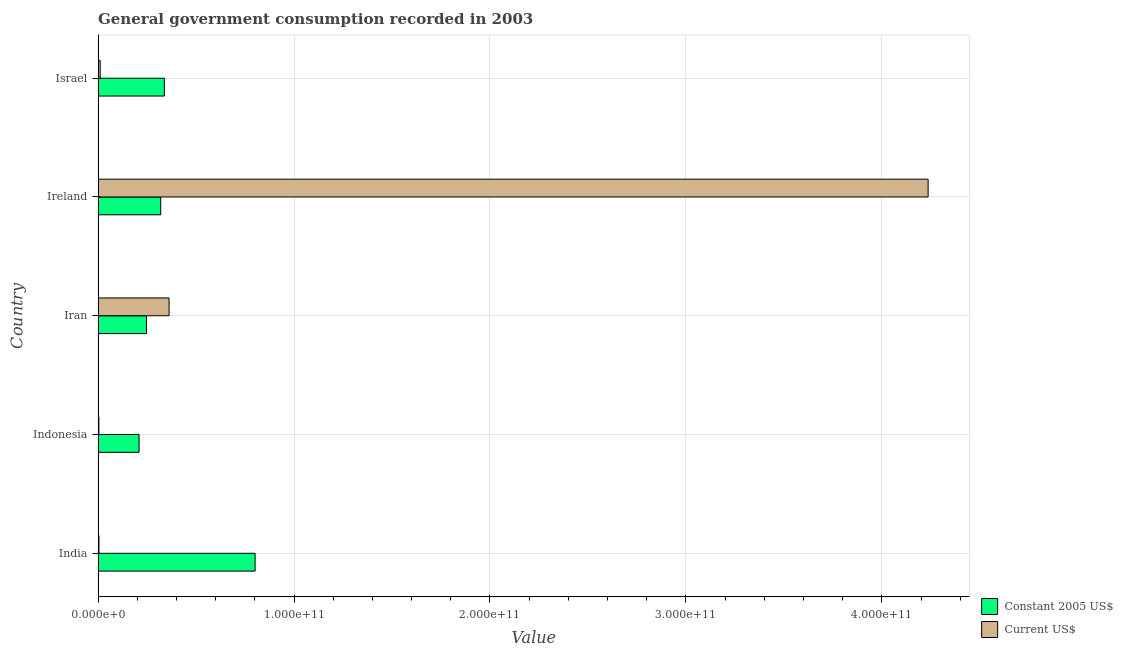How many groups of bars are there?
Your answer should be compact. 5. Are the number of bars on each tick of the Y-axis equal?
Your answer should be compact. Yes. What is the label of the 3rd group of bars from the top?
Offer a very short reply. Iran. What is the value consumed in constant 2005 us$ in Iran?
Your answer should be very brief. 2.47e+1. Across all countries, what is the maximum value consumed in current us$?
Provide a short and direct response. 4.24e+11. Across all countries, what is the minimum value consumed in current us$?
Your response must be concise. 3.86e+08. In which country was the value consumed in constant 2005 us$ maximum?
Your answer should be compact. India. In which country was the value consumed in current us$ minimum?
Your answer should be compact. Indonesia. What is the total value consumed in constant 2005 us$ in the graph?
Your answer should be compact. 1.91e+11. What is the difference between the value consumed in current us$ in Ireland and that in Israel?
Ensure brevity in your answer.  4.23e+11. What is the difference between the value consumed in current us$ in Iran and the value consumed in constant 2005 us$ in Israel?
Offer a terse response. 2.40e+09. What is the average value consumed in current us$ per country?
Your response must be concise. 9.23e+1. What is the difference between the value consumed in constant 2005 us$ and value consumed in current us$ in Ireland?
Offer a very short reply. -3.92e+11. In how many countries, is the value consumed in constant 2005 us$ greater than 20000000000 ?
Make the answer very short. 5. What is the ratio of the value consumed in constant 2005 us$ in Iran to that in Ireland?
Provide a succinct answer. 0.77. What is the difference between the highest and the second highest value consumed in current us$?
Provide a short and direct response. 3.87e+11. What is the difference between the highest and the lowest value consumed in current us$?
Provide a short and direct response. 4.23e+11. In how many countries, is the value consumed in current us$ greater than the average value consumed in current us$ taken over all countries?
Keep it short and to the point. 1. What does the 1st bar from the top in Indonesia represents?
Your answer should be compact. Current US$. What does the 2nd bar from the bottom in Ireland represents?
Give a very brief answer. Current US$. How many bars are there?
Keep it short and to the point. 10. Are all the bars in the graph horizontal?
Provide a short and direct response. Yes. What is the difference between two consecutive major ticks on the X-axis?
Give a very brief answer. 1.00e+11. Are the values on the major ticks of X-axis written in scientific E-notation?
Keep it short and to the point. Yes. Does the graph contain any zero values?
Keep it short and to the point. No. Where does the legend appear in the graph?
Make the answer very short. Bottom right. How are the legend labels stacked?
Your response must be concise. Vertical. What is the title of the graph?
Provide a succinct answer. General government consumption recorded in 2003. Does "Methane emissions" appear as one of the legend labels in the graph?
Provide a short and direct response. No. What is the label or title of the X-axis?
Provide a succinct answer. Value. What is the Value of Constant 2005 US$ in India?
Offer a terse response. 8.01e+1. What is the Value in Current US$ in India?
Provide a succinct answer. 4.29e+08. What is the Value in Constant 2005 US$ in Indonesia?
Your response must be concise. 2.09e+1. What is the Value in Current US$ in Indonesia?
Your response must be concise. 3.86e+08. What is the Value in Constant 2005 US$ in Iran?
Your answer should be very brief. 2.47e+1. What is the Value in Current US$ in Iran?
Give a very brief answer. 3.62e+1. What is the Value of Constant 2005 US$ in Ireland?
Keep it short and to the point. 3.19e+1. What is the Value of Current US$ in Ireland?
Your response must be concise. 4.24e+11. What is the Value in Constant 2005 US$ in Israel?
Your answer should be very brief. 3.38e+1. What is the Value in Current US$ in Israel?
Keep it short and to the point. 1.05e+09. Across all countries, what is the maximum Value in Constant 2005 US$?
Your response must be concise. 8.01e+1. Across all countries, what is the maximum Value of Current US$?
Ensure brevity in your answer.  4.24e+11. Across all countries, what is the minimum Value of Constant 2005 US$?
Provide a succinct answer. 2.09e+1. Across all countries, what is the minimum Value of Current US$?
Provide a short and direct response. 3.86e+08. What is the total Value in Constant 2005 US$ in the graph?
Provide a short and direct response. 1.91e+11. What is the total Value of Current US$ in the graph?
Provide a short and direct response. 4.62e+11. What is the difference between the Value of Constant 2005 US$ in India and that in Indonesia?
Your answer should be very brief. 5.92e+1. What is the difference between the Value of Current US$ in India and that in Indonesia?
Keep it short and to the point. 4.30e+07. What is the difference between the Value of Constant 2005 US$ in India and that in Iran?
Keep it short and to the point. 5.55e+1. What is the difference between the Value in Current US$ in India and that in Iran?
Your answer should be very brief. -3.58e+1. What is the difference between the Value of Constant 2005 US$ in India and that in Ireland?
Your answer should be compact. 4.82e+1. What is the difference between the Value of Current US$ in India and that in Ireland?
Provide a succinct answer. -4.23e+11. What is the difference between the Value of Constant 2005 US$ in India and that in Israel?
Provide a succinct answer. 4.63e+1. What is the difference between the Value in Current US$ in India and that in Israel?
Ensure brevity in your answer.  -6.24e+08. What is the difference between the Value of Constant 2005 US$ in Indonesia and that in Iran?
Your answer should be compact. -3.77e+09. What is the difference between the Value in Current US$ in Indonesia and that in Iran?
Make the answer very short. -3.58e+1. What is the difference between the Value in Constant 2005 US$ in Indonesia and that in Ireland?
Keep it short and to the point. -1.10e+1. What is the difference between the Value of Current US$ in Indonesia and that in Ireland?
Make the answer very short. -4.23e+11. What is the difference between the Value of Constant 2005 US$ in Indonesia and that in Israel?
Keep it short and to the point. -1.29e+1. What is the difference between the Value of Current US$ in Indonesia and that in Israel?
Make the answer very short. -6.67e+08. What is the difference between the Value in Constant 2005 US$ in Iran and that in Ireland?
Keep it short and to the point. -7.27e+09. What is the difference between the Value in Current US$ in Iran and that in Ireland?
Offer a terse response. -3.87e+11. What is the difference between the Value of Constant 2005 US$ in Iran and that in Israel?
Make the answer very short. -9.13e+09. What is the difference between the Value of Current US$ in Iran and that in Israel?
Give a very brief answer. 3.52e+1. What is the difference between the Value in Constant 2005 US$ in Ireland and that in Israel?
Offer a terse response. -1.86e+09. What is the difference between the Value in Current US$ in Ireland and that in Israel?
Provide a short and direct response. 4.23e+11. What is the difference between the Value in Constant 2005 US$ in India and the Value in Current US$ in Indonesia?
Ensure brevity in your answer.  7.97e+1. What is the difference between the Value in Constant 2005 US$ in India and the Value in Current US$ in Iran?
Provide a succinct answer. 4.39e+1. What is the difference between the Value of Constant 2005 US$ in India and the Value of Current US$ in Ireland?
Provide a succinct answer. -3.44e+11. What is the difference between the Value in Constant 2005 US$ in India and the Value in Current US$ in Israel?
Keep it short and to the point. 7.91e+1. What is the difference between the Value in Constant 2005 US$ in Indonesia and the Value in Current US$ in Iran?
Offer a very short reply. -1.53e+1. What is the difference between the Value of Constant 2005 US$ in Indonesia and the Value of Current US$ in Ireland?
Make the answer very short. -4.03e+11. What is the difference between the Value in Constant 2005 US$ in Indonesia and the Value in Current US$ in Israel?
Ensure brevity in your answer.  1.99e+1. What is the difference between the Value in Constant 2005 US$ in Iran and the Value in Current US$ in Ireland?
Ensure brevity in your answer.  -3.99e+11. What is the difference between the Value in Constant 2005 US$ in Iran and the Value in Current US$ in Israel?
Ensure brevity in your answer.  2.36e+1. What is the difference between the Value of Constant 2005 US$ in Ireland and the Value of Current US$ in Israel?
Make the answer very short. 3.09e+1. What is the average Value of Constant 2005 US$ per country?
Ensure brevity in your answer.  3.83e+1. What is the average Value in Current US$ per country?
Make the answer very short. 9.23e+1. What is the difference between the Value in Constant 2005 US$ and Value in Current US$ in India?
Provide a short and direct response. 7.97e+1. What is the difference between the Value of Constant 2005 US$ and Value of Current US$ in Indonesia?
Offer a very short reply. 2.05e+1. What is the difference between the Value in Constant 2005 US$ and Value in Current US$ in Iran?
Provide a short and direct response. -1.15e+1. What is the difference between the Value of Constant 2005 US$ and Value of Current US$ in Ireland?
Offer a very short reply. -3.92e+11. What is the difference between the Value of Constant 2005 US$ and Value of Current US$ in Israel?
Offer a terse response. 3.28e+1. What is the ratio of the Value in Constant 2005 US$ in India to that in Indonesia?
Offer a terse response. 3.83. What is the ratio of the Value of Current US$ in India to that in Indonesia?
Make the answer very short. 1.11. What is the ratio of the Value in Constant 2005 US$ in India to that in Iran?
Your answer should be very brief. 3.25. What is the ratio of the Value in Current US$ in India to that in Iran?
Keep it short and to the point. 0.01. What is the ratio of the Value of Constant 2005 US$ in India to that in Ireland?
Give a very brief answer. 2.51. What is the ratio of the Value of Constant 2005 US$ in India to that in Israel?
Make the answer very short. 2.37. What is the ratio of the Value of Current US$ in India to that in Israel?
Provide a succinct answer. 0.41. What is the ratio of the Value of Constant 2005 US$ in Indonesia to that in Iran?
Provide a short and direct response. 0.85. What is the ratio of the Value of Current US$ in Indonesia to that in Iran?
Your response must be concise. 0.01. What is the ratio of the Value of Constant 2005 US$ in Indonesia to that in Ireland?
Offer a terse response. 0.65. What is the ratio of the Value in Current US$ in Indonesia to that in Ireland?
Offer a very short reply. 0. What is the ratio of the Value in Constant 2005 US$ in Indonesia to that in Israel?
Provide a short and direct response. 0.62. What is the ratio of the Value in Current US$ in Indonesia to that in Israel?
Your response must be concise. 0.37. What is the ratio of the Value of Constant 2005 US$ in Iran to that in Ireland?
Offer a terse response. 0.77. What is the ratio of the Value in Current US$ in Iran to that in Ireland?
Ensure brevity in your answer.  0.09. What is the ratio of the Value of Constant 2005 US$ in Iran to that in Israel?
Make the answer very short. 0.73. What is the ratio of the Value in Current US$ in Iran to that in Israel?
Ensure brevity in your answer.  34.4. What is the ratio of the Value in Constant 2005 US$ in Ireland to that in Israel?
Keep it short and to the point. 0.94. What is the ratio of the Value of Current US$ in Ireland to that in Israel?
Offer a very short reply. 402.47. What is the difference between the highest and the second highest Value in Constant 2005 US$?
Ensure brevity in your answer.  4.63e+1. What is the difference between the highest and the second highest Value in Current US$?
Offer a terse response. 3.87e+11. What is the difference between the highest and the lowest Value of Constant 2005 US$?
Ensure brevity in your answer.  5.92e+1. What is the difference between the highest and the lowest Value in Current US$?
Provide a short and direct response. 4.23e+11. 